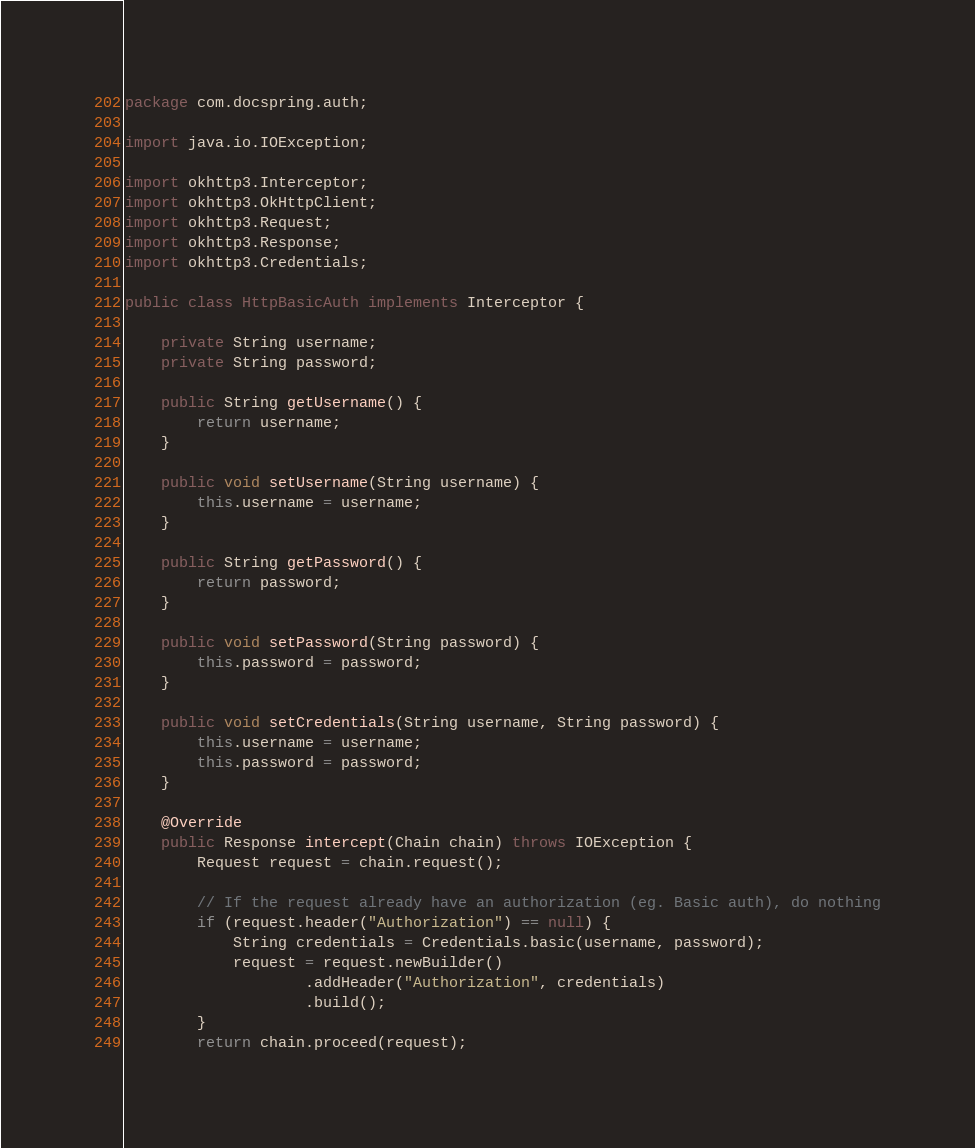<code> <loc_0><loc_0><loc_500><loc_500><_Java_>package com.docspring.auth;

import java.io.IOException;

import okhttp3.Interceptor;
import okhttp3.OkHttpClient;
import okhttp3.Request;
import okhttp3.Response;
import okhttp3.Credentials;

public class HttpBasicAuth implements Interceptor {

    private String username;
    private String password;
    
    public String getUsername() {
        return username;
    }

    public void setUsername(String username) {
        this.username = username;
    }

    public String getPassword() {
        return password;
    }

    public void setPassword(String password) {
        this.password = password;
    }

    public void setCredentials(String username, String password) {
        this.username = username;
        this.password = password;
    }

    @Override
    public Response intercept(Chain chain) throws IOException {
        Request request = chain.request();

        // If the request already have an authorization (eg. Basic auth), do nothing
        if (request.header("Authorization") == null) {
            String credentials = Credentials.basic(username, password);
            request = request.newBuilder()
                    .addHeader("Authorization", credentials)
                    .build();
        }
        return chain.proceed(request);</code> 